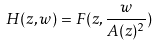<formula> <loc_0><loc_0><loc_500><loc_500>H ( z , w ) = F ( z , \frac { w } { A ( z ) ^ { 2 } } )</formula> 